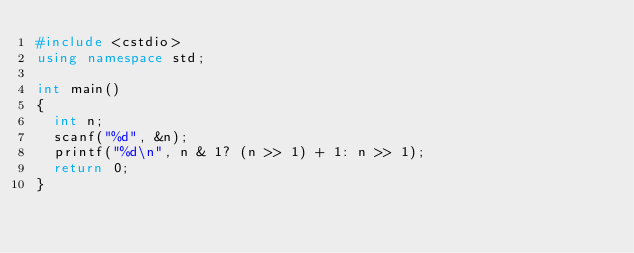Convert code to text. <code><loc_0><loc_0><loc_500><loc_500><_C++_>#include <cstdio>
using namespace std;

int main()
{
  int n;
  scanf("%d", &n);
  printf("%d\n", n & 1? (n >> 1) + 1: n >> 1);
  return 0;
}</code> 